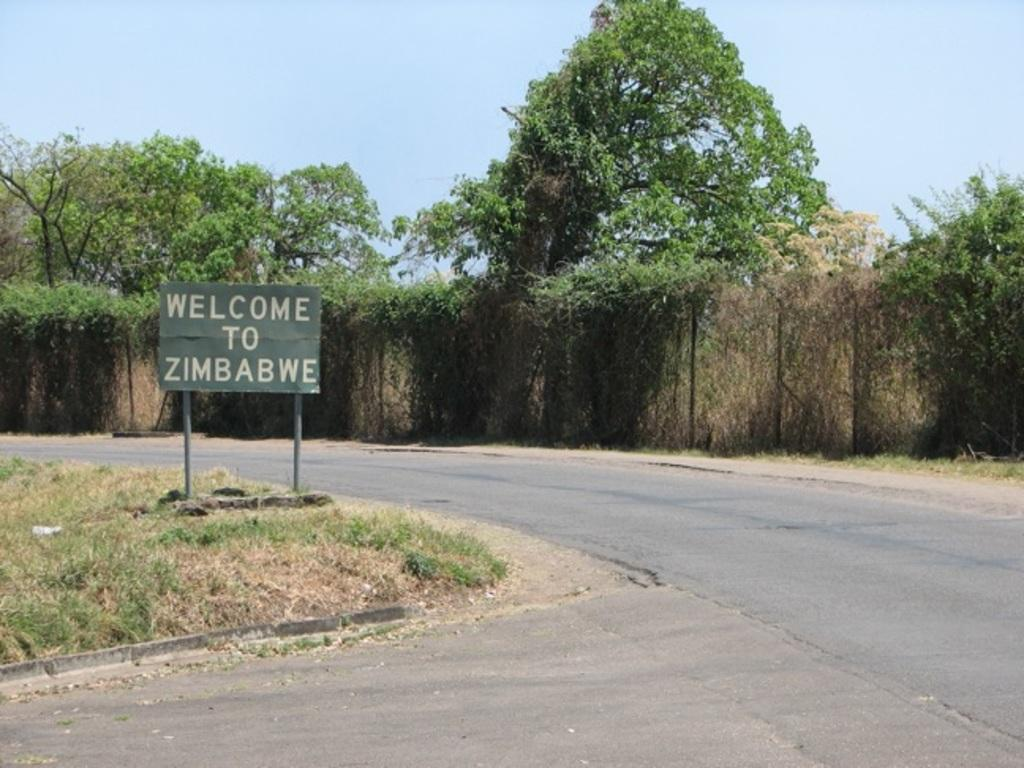What is written or displayed on the board in the image? There is text on a board in the image. What type of surface is beneath the board? There is grass on the ground in the image. What type of pathway is visible in the image? There is a road visible in the image. What can be seen in the distance behind the board? There are plants and trees in the background of the image. Is there a river flowing through the image? No, there is no river visible in the image. Can you describe the paint color of the stranger in the image? There is no stranger present in the image, so we cannot describe their paint color. 